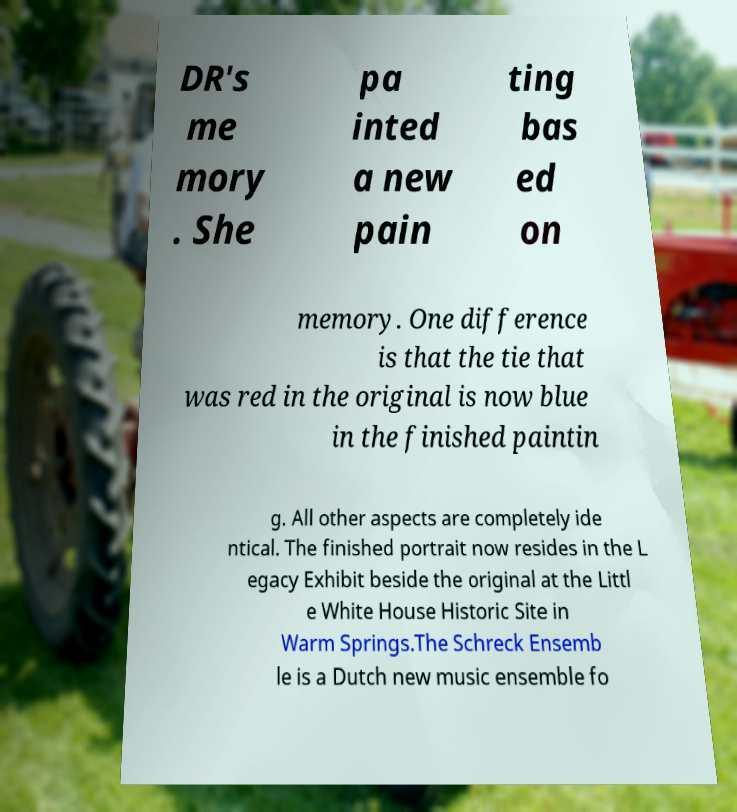Please read and relay the text visible in this image. What does it say? DR's me mory . She pa inted a new pain ting bas ed on memory. One difference is that the tie that was red in the original is now blue in the finished paintin g. All other aspects are completely ide ntical. The finished portrait now resides in the L egacy Exhibit beside the original at the Littl e White House Historic Site in Warm Springs.The Schreck Ensemb le is a Dutch new music ensemble fo 